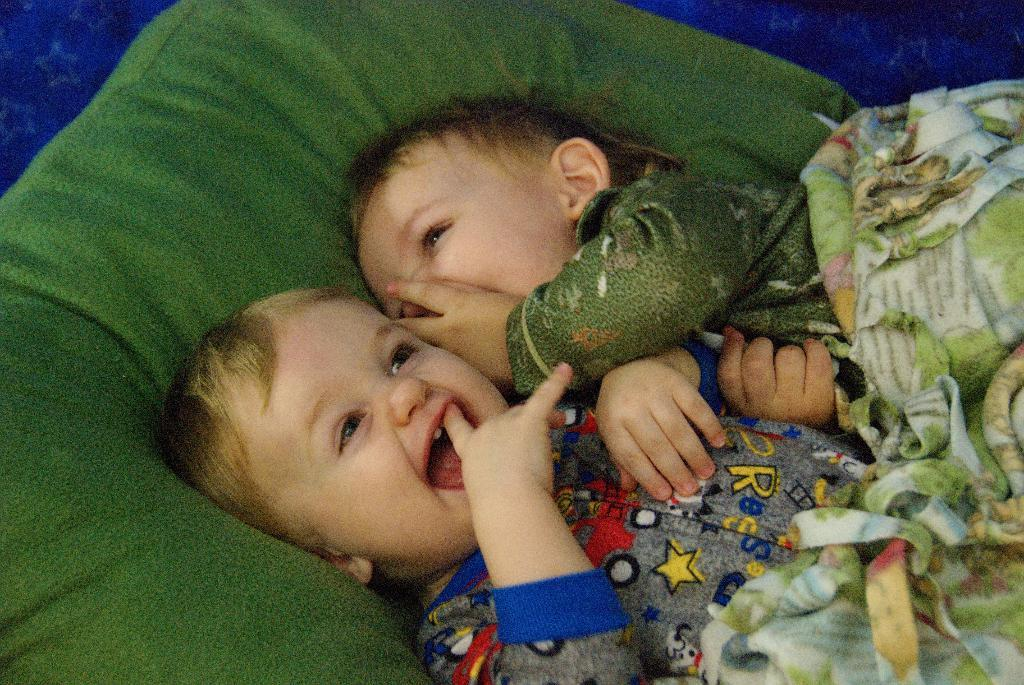How many babies are present in the image? There are two babies in the image. What is the color of the bed on which the babies are laying? The bed has a green color bed sheet. What is the position of the babies on the bed? The babies are laying on the bed. What is the emotional state of the babies in the image? The babies are smiling. What type of hose can be seen spraying water on the babies in the image? There is no hose present in the image, and the babies are not being sprayed with water. What type of fork is the baby holding in the image? There are no forks present in the image, and the babies are not holding any utensils. 